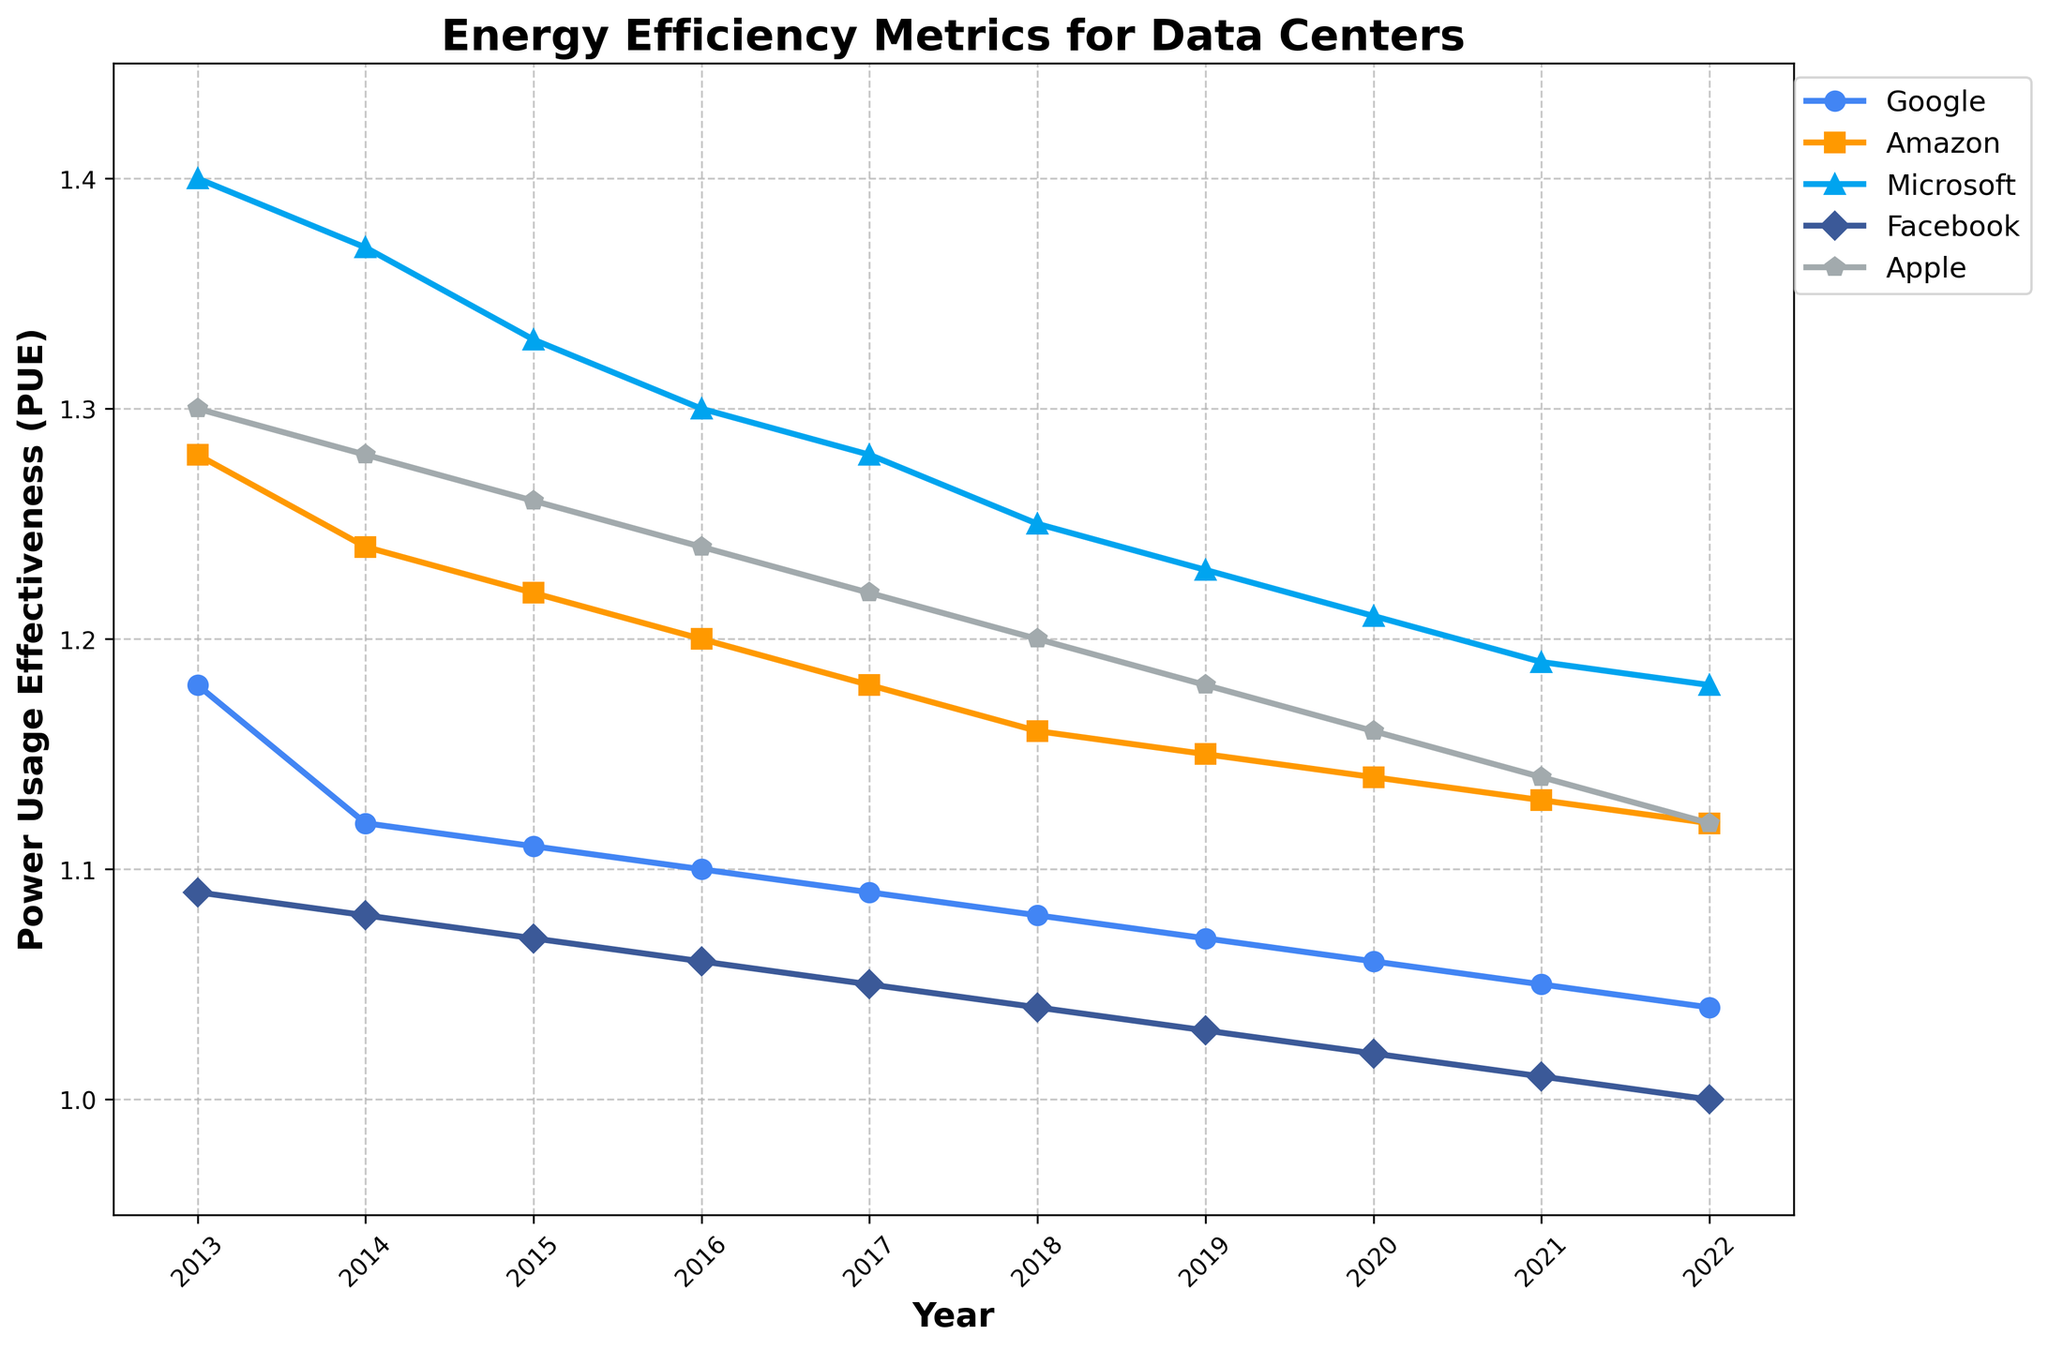Which company had the highest PUE in 2013? Look at the data values for the year 2013 and compare the PUE values across all companies. Microsoft has the highest value at 1.40.
Answer: Microsoft How did Facebook's PUE change from 2013 to 2022? Compare Facebook's PUE value in 2013 (1.09) with its value in 2022 (1.00). Facebook's PUE decreased by 0.09.
Answer: Decreased Which two companies showed the most significant improvement in their PUE over the past decade? Calculate the difference in PUE from 2013 to 2022 for all companies. Facebook improved by 0.09 (1.09 - 1.00), and Google improved by 0.14 (1.18 - 1.04). Thus, Facebook and Google showed the most significant improvement.
Answer: Facebook and Google Between Google and Apple, which company had a lower PUE in the year 2018? Compare Google's PUE (1.08) with Apple's PUE (1.20) in 2018. Google had a lower PUE.
Answer: Google What is the average PUE of Amazon's data centers over the period from 2013 to 2022? Sum up Amazon's PUE values from all years (1.28 + 1.24 + 1.22 + 1.20 + 1.18 + 1.16 + 1.15 + 1.14 + 1.13 + 1.12) and divide by the number of years (10). The average PUE is (11.82/10).
Answer: 1.182 Which company has the most consistent PUE trend over the years? Look at the general trends of the lines for all companies. Facebook's PUE shows a consistent linear decrease with the smoothest slope among all.
Answer: Facebook In what year did Microsoft’s PUE become less than 1.30 for the first time? Identify the year when Microsoft’s PUE first dropped below 1.30. In 2017, it reached 1.28.
Answer: 2017 Compare the PUE between Google and Amazon in 2020. Which company had a more efficient data center? Compare the PUE values for Google (1.06) and Amazon (1.14) in 2020. Google had a more efficient data center due to a lower PUE.
Answer: Google 